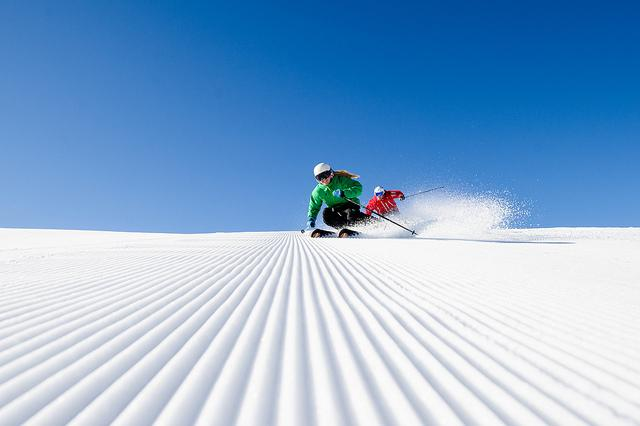The person in the lead is wearing what color jacket? green 